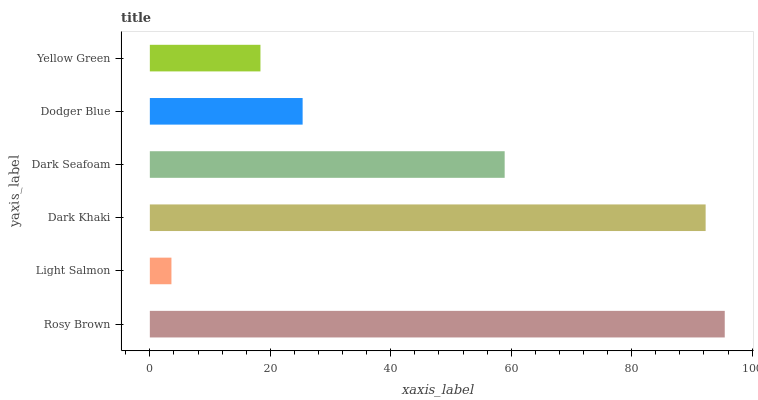Is Light Salmon the minimum?
Answer yes or no. Yes. Is Rosy Brown the maximum?
Answer yes or no. Yes. Is Dark Khaki the minimum?
Answer yes or no. No. Is Dark Khaki the maximum?
Answer yes or no. No. Is Dark Khaki greater than Light Salmon?
Answer yes or no. Yes. Is Light Salmon less than Dark Khaki?
Answer yes or no. Yes. Is Light Salmon greater than Dark Khaki?
Answer yes or no. No. Is Dark Khaki less than Light Salmon?
Answer yes or no. No. Is Dark Seafoam the high median?
Answer yes or no. Yes. Is Dodger Blue the low median?
Answer yes or no. Yes. Is Dodger Blue the high median?
Answer yes or no. No. Is Dark Seafoam the low median?
Answer yes or no. No. 